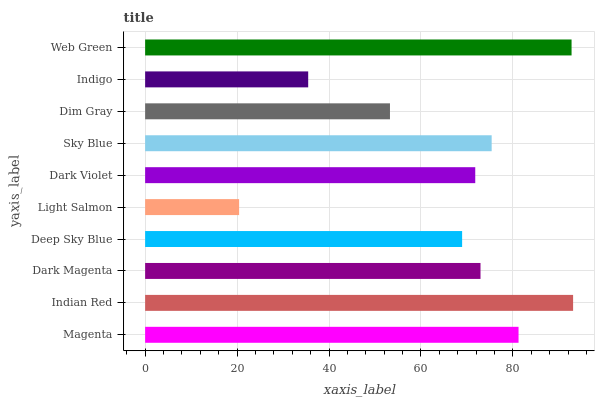Is Light Salmon the minimum?
Answer yes or no. Yes. Is Indian Red the maximum?
Answer yes or no. Yes. Is Dark Magenta the minimum?
Answer yes or no. No. Is Dark Magenta the maximum?
Answer yes or no. No. Is Indian Red greater than Dark Magenta?
Answer yes or no. Yes. Is Dark Magenta less than Indian Red?
Answer yes or no. Yes. Is Dark Magenta greater than Indian Red?
Answer yes or no. No. Is Indian Red less than Dark Magenta?
Answer yes or no. No. Is Dark Magenta the high median?
Answer yes or no. Yes. Is Dark Violet the low median?
Answer yes or no. Yes. Is Indigo the high median?
Answer yes or no. No. Is Light Salmon the low median?
Answer yes or no. No. 